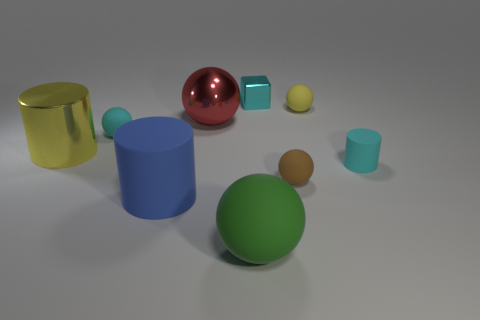There is a yellow thing that is on the right side of the red metallic thing; does it have the same size as the yellow thing on the left side of the green object? No, the yellow object on the right side of the red metallic sphere is smaller in size compared to the yellow object on the left side of the green cylinder. 